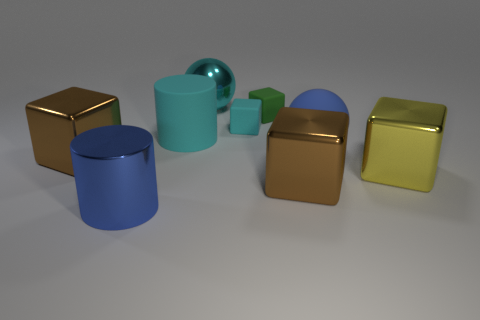Subtract all yellow metal blocks. How many blocks are left? 4 Add 1 cyan cylinders. How many objects exist? 10 Subtract all large objects. Subtract all large shiny cylinders. How many objects are left? 1 Add 3 big yellow blocks. How many big yellow blocks are left? 4 Add 5 tiny blocks. How many tiny blocks exist? 7 Subtract all cyan cylinders. How many cylinders are left? 1 Subtract 2 brown cubes. How many objects are left? 7 Subtract all blocks. How many objects are left? 4 Subtract 3 blocks. How many blocks are left? 2 Subtract all brown cylinders. Subtract all gray balls. How many cylinders are left? 2 